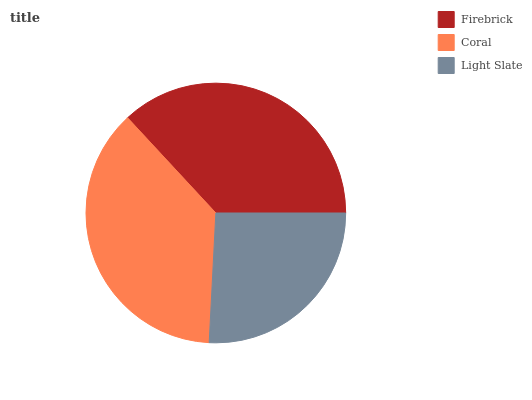Is Light Slate the minimum?
Answer yes or no. Yes. Is Coral the maximum?
Answer yes or no. Yes. Is Coral the minimum?
Answer yes or no. No. Is Light Slate the maximum?
Answer yes or no. No. Is Coral greater than Light Slate?
Answer yes or no. Yes. Is Light Slate less than Coral?
Answer yes or no. Yes. Is Light Slate greater than Coral?
Answer yes or no. No. Is Coral less than Light Slate?
Answer yes or no. No. Is Firebrick the high median?
Answer yes or no. Yes. Is Firebrick the low median?
Answer yes or no. Yes. Is Coral the high median?
Answer yes or no. No. Is Coral the low median?
Answer yes or no. No. 